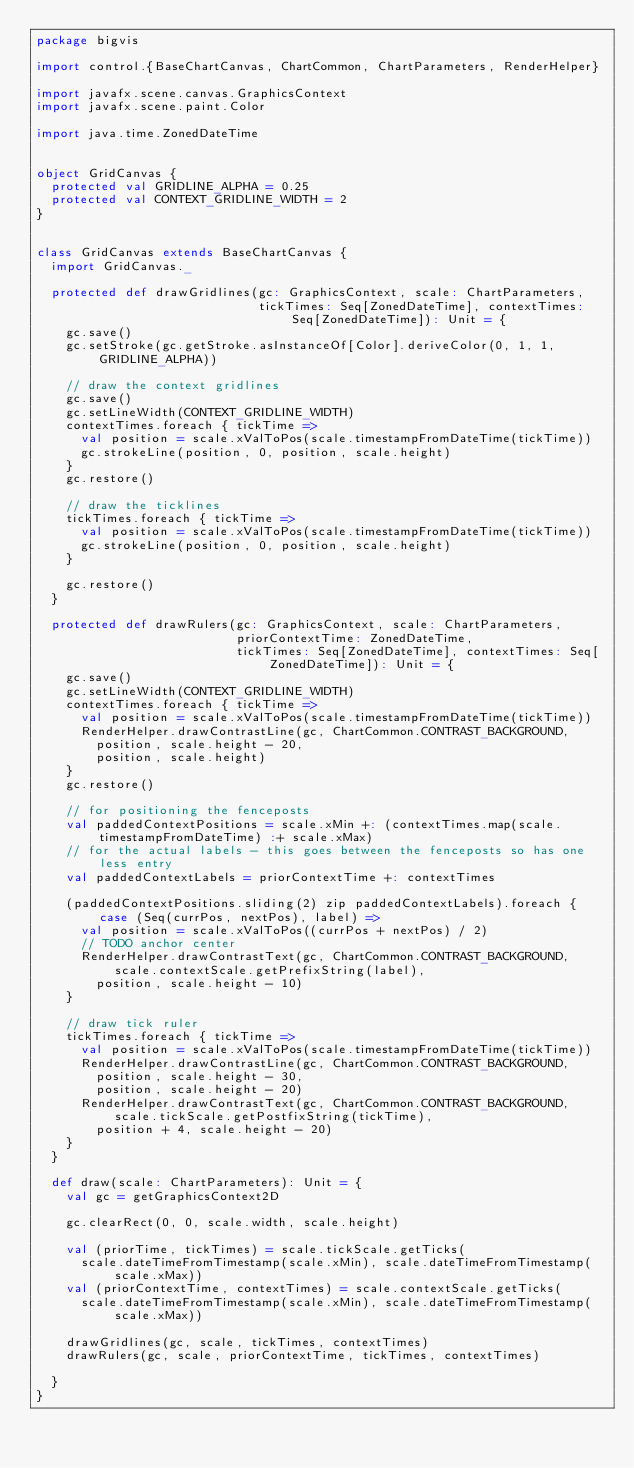Convert code to text. <code><loc_0><loc_0><loc_500><loc_500><_Scala_>package bigvis

import control.{BaseChartCanvas, ChartCommon, ChartParameters, RenderHelper}

import javafx.scene.canvas.GraphicsContext
import javafx.scene.paint.Color

import java.time.ZonedDateTime


object GridCanvas {
  protected val GRIDLINE_ALPHA = 0.25
  protected val CONTEXT_GRIDLINE_WIDTH = 2
}


class GridCanvas extends BaseChartCanvas {
  import GridCanvas._

  protected def drawGridlines(gc: GraphicsContext, scale: ChartParameters,
                              tickTimes: Seq[ZonedDateTime], contextTimes: Seq[ZonedDateTime]): Unit = {
    gc.save()
    gc.setStroke(gc.getStroke.asInstanceOf[Color].deriveColor(0, 1, 1, GRIDLINE_ALPHA))

    // draw the context gridlines
    gc.save()
    gc.setLineWidth(CONTEXT_GRIDLINE_WIDTH)
    contextTimes.foreach { tickTime =>
      val position = scale.xValToPos(scale.timestampFromDateTime(tickTime))
      gc.strokeLine(position, 0, position, scale.height)
    }
    gc.restore()

    // draw the ticklines
    tickTimes.foreach { tickTime =>
      val position = scale.xValToPos(scale.timestampFromDateTime(tickTime))
      gc.strokeLine(position, 0, position, scale.height)
    }

    gc.restore()
  }

  protected def drawRulers(gc: GraphicsContext, scale: ChartParameters,
                           priorContextTime: ZonedDateTime,
                           tickTimes: Seq[ZonedDateTime], contextTimes: Seq[ZonedDateTime]): Unit = {
    gc.save()
    gc.setLineWidth(CONTEXT_GRIDLINE_WIDTH)
    contextTimes.foreach { tickTime =>
      val position = scale.xValToPos(scale.timestampFromDateTime(tickTime))
      RenderHelper.drawContrastLine(gc, ChartCommon.CONTRAST_BACKGROUND,
        position, scale.height - 20,
        position, scale.height)
    }
    gc.restore()

    // for positioning the fenceposts
    val paddedContextPositions = scale.xMin +: (contextTimes.map(scale.timestampFromDateTime) :+ scale.xMax)
    // for the actual labels - this goes between the fenceposts so has one less entry
    val paddedContextLabels = priorContextTime +: contextTimes

    (paddedContextPositions.sliding(2) zip paddedContextLabels).foreach { case (Seq(currPos, nextPos), label) =>
      val position = scale.xValToPos((currPos + nextPos) / 2)
      // TODO anchor center
      RenderHelper.drawContrastText(gc, ChartCommon.CONTRAST_BACKGROUND, scale.contextScale.getPrefixString(label),
        position, scale.height - 10)
    }

    // draw tick ruler
    tickTimes.foreach { tickTime =>
      val position = scale.xValToPos(scale.timestampFromDateTime(tickTime))
      RenderHelper.drawContrastLine(gc, ChartCommon.CONTRAST_BACKGROUND,
        position, scale.height - 30,
        position, scale.height - 20)
      RenderHelper.drawContrastText(gc, ChartCommon.CONTRAST_BACKGROUND, scale.tickScale.getPostfixString(tickTime),
        position + 4, scale.height - 20)
    }
  }

  def draw(scale: ChartParameters): Unit = {
    val gc = getGraphicsContext2D

    gc.clearRect(0, 0, scale.width, scale.height)

    val (priorTime, tickTimes) = scale.tickScale.getTicks(
      scale.dateTimeFromTimestamp(scale.xMin), scale.dateTimeFromTimestamp(scale.xMax))
    val (priorContextTime, contextTimes) = scale.contextScale.getTicks(
      scale.dateTimeFromTimestamp(scale.xMin), scale.dateTimeFromTimestamp(scale.xMax))

    drawGridlines(gc, scale, tickTimes, contextTimes)
    drawRulers(gc, scale, priorContextTime, tickTimes, contextTimes)

  }
}
</code> 